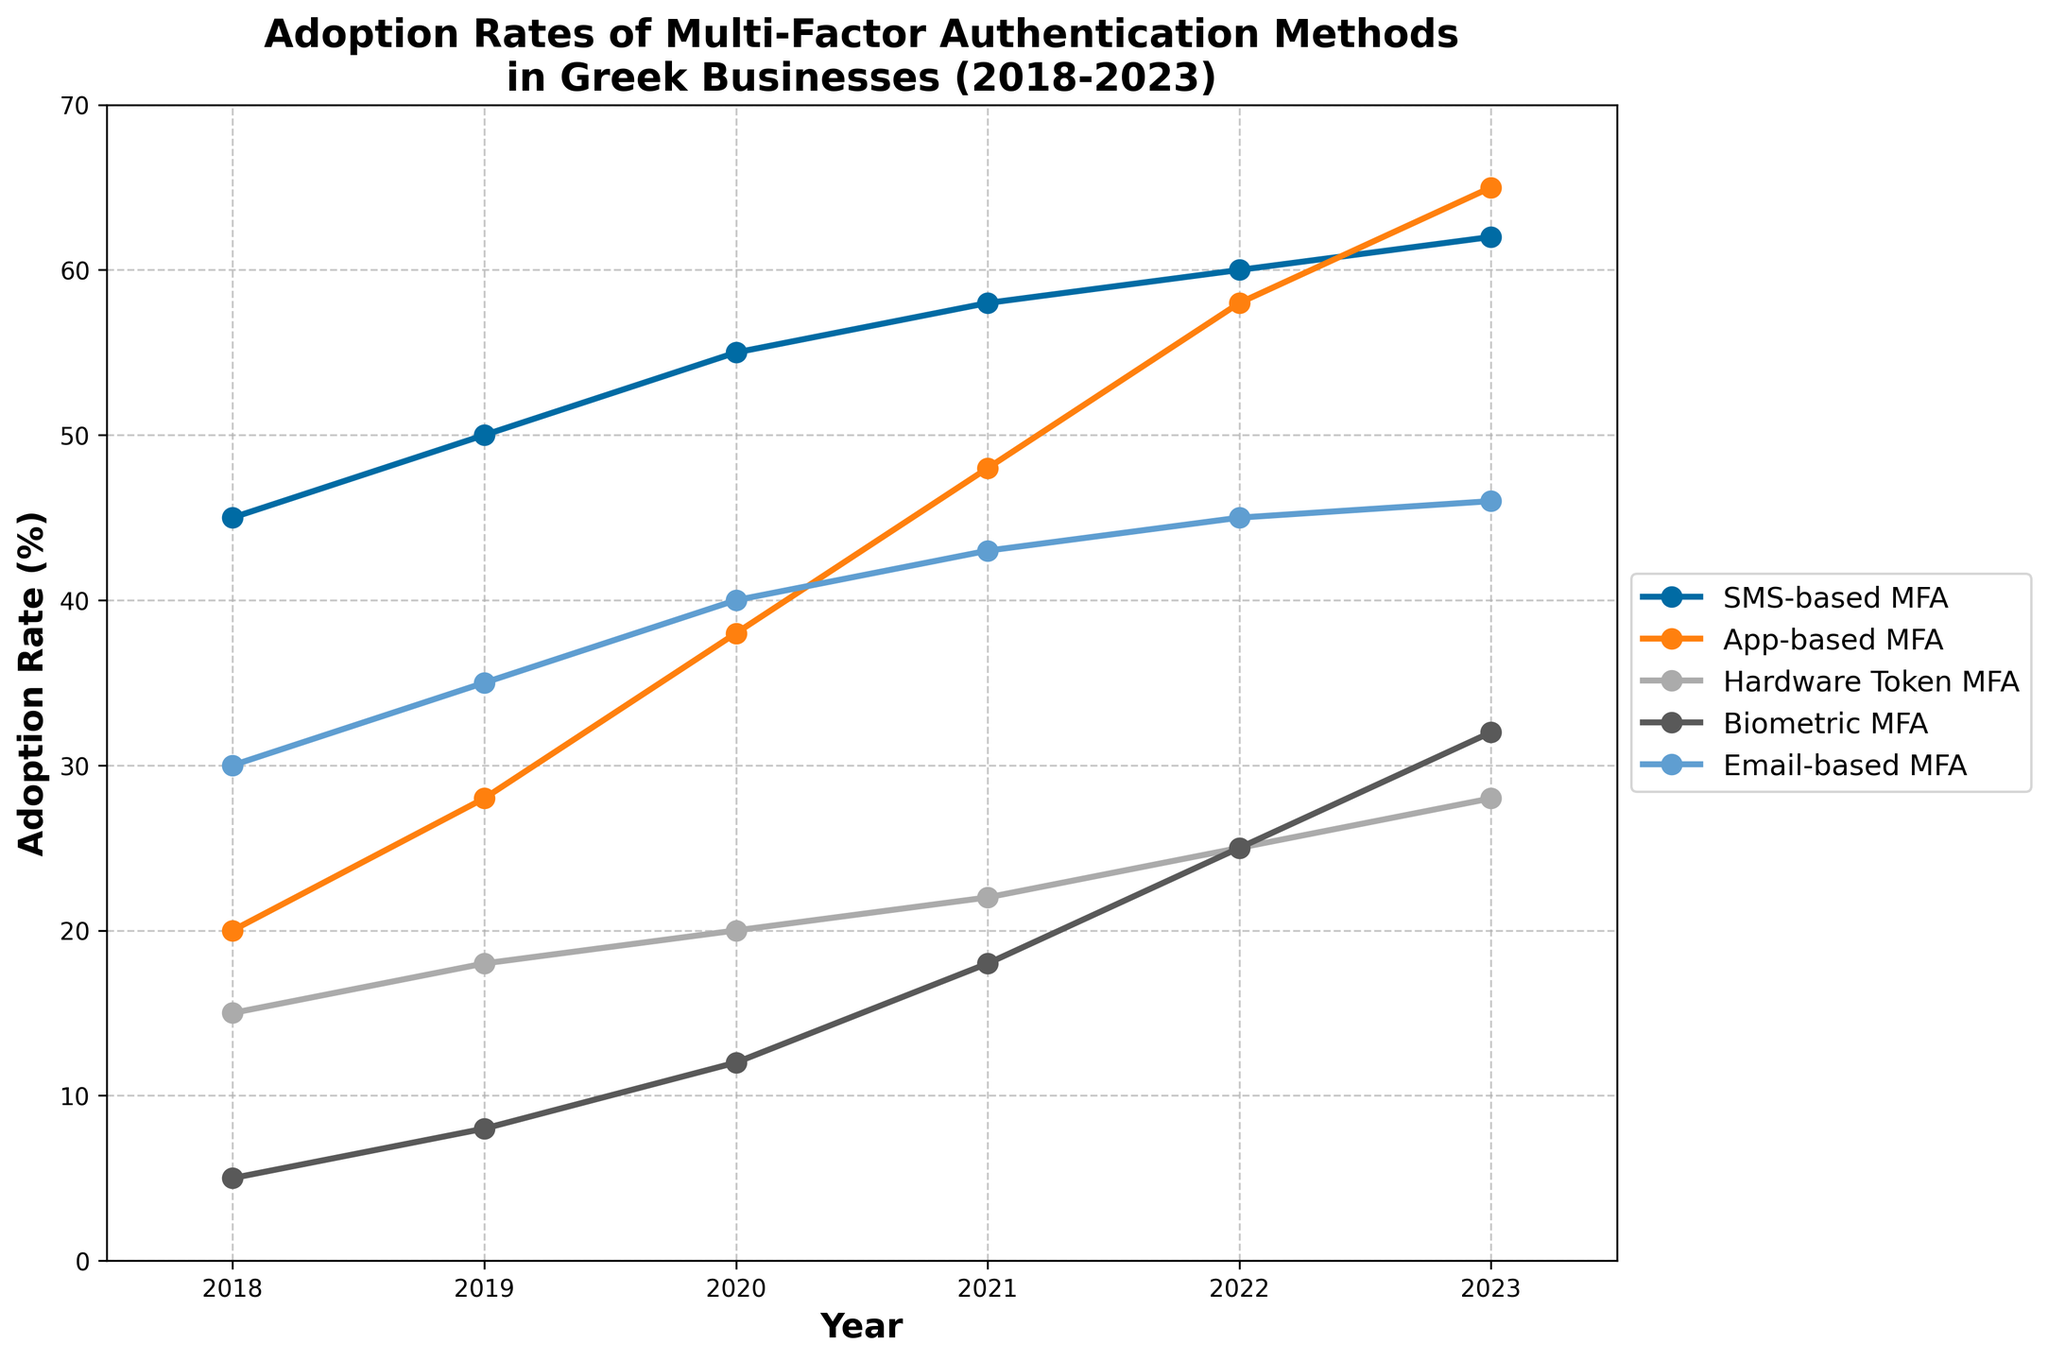What is the adoption rate of App-based MFA in 2020? In the plot, we find the year 2020 along the x-axis and move vertically until reaching the line representing App-based MFA, which is marked by a point. The y-axis value corresponding to this point gives us the adoption rate.
Answer: 38 Which MFA method had the highest adoption rate in 2021? To find this, look for the year 2021 on the x-axis and compare the y-axis values of all MFA methods. The highest point should indicate the method with the highest adoption rate.
Answer: SMS-based MFA How much did the adoption rate of Biometric MFA increase from 2019 to 2023? First, locate the data points for Biometric MFA in 2019 and 2023 by following the respective years on the x-axis. Then, read the y-axis values for these points and calculate the difference between the two.
Answer: 24 What was the total adoption rate across all MFA methods in 2022? Sum the adoption rates for all MFA methods in 2022 by adding the y-axis values for each method in that year.
Answer: 213 Which MFA method saw the greatest increase in adoption rate from 2018 to 2023? Examine each MFA method and calculate the difference in adoption rates between 2018 and 2023 by subtracting the 2018 value from the 2023 value for each method. Identify the largest difference.
Answer: App-based MFA Compare the adoption rates of Hardware Token MFA and Email-based MFA in 2020. Which one is higher? Locate the respective adoption rates for both Hardware Token MFA and Email-based MFA in the year 2020 by reading the y-axis values. Compare these two values to see which one is greater.
Answer: Email-based MFA What is the average adoption rate of SMS-based MFA over the 5 years shown? To find the average, add the adoption rates of SMS-based MFA for all the given years and then divide by the number of years (6 years).
Answer: 55 Which MFA method had the least adoption rate in 2018? Look at the data points for each MFA method in the year 2018 and identify the one closest to the x-axis, indicating the lowest y-axis value.
Answer: Biometric MFA In which year did App-based MFA surpass SMS-based MFA in adoption rates? Follow the lines representing App-based MFA and SMS-based MFA across the years until the App-based MFA line rises above the SMS-based MFA line. Identify the corresponding year at this intersection.
Answer: 2023 